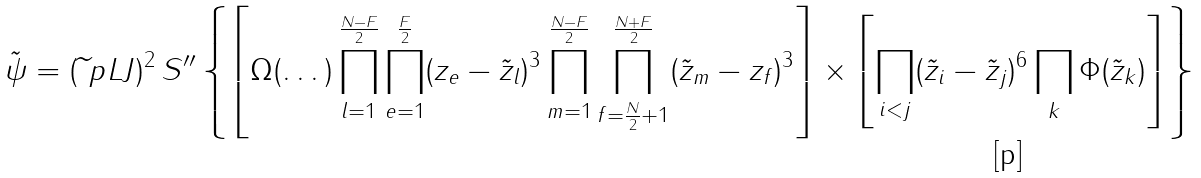Convert formula to latex. <formula><loc_0><loc_0><loc_500><loc_500>\tilde { \psi } = ( \widetilde { \ } p L J ) ^ { 2 } \, S ^ { \prime \prime } \left \{ \left [ \Omega ( \dots ) \prod _ { l = 1 } ^ { \frac { N - F } { 2 } } \prod _ { e = 1 } ^ { \frac { F } { 2 } } ( z _ { e } - \tilde { z } _ { l } ) ^ { 3 } \prod _ { m = 1 } ^ { \frac { N - F } { 2 } } \prod _ { f = \frac { N } { 2 } + 1 } ^ { \frac { N + F } { 2 } } ( \tilde { z } _ { m } - z _ { f } ) ^ { 3 } \right ] \times \left [ \prod _ { i < j } ( \tilde { z } _ { i } - \tilde { z } _ { j } ) ^ { 6 } \prod _ { k } \Phi ( \tilde { z } _ { k } ) \right ] \right \}</formula> 